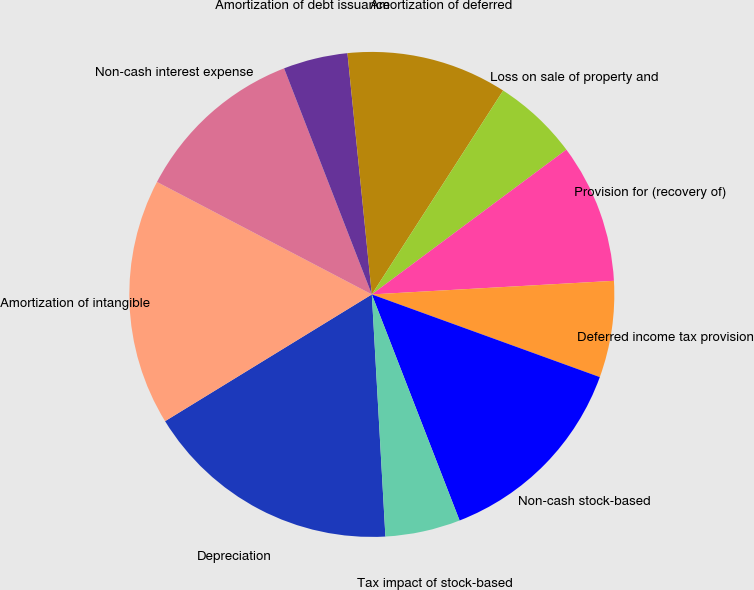Convert chart to OTSL. <chart><loc_0><loc_0><loc_500><loc_500><pie_chart><fcel>Depreciation<fcel>Amortization of intangible<fcel>Non-cash interest expense<fcel>Amortization of debt issuance<fcel>Amortization of deferred<fcel>Loss on sale of property and<fcel>Provision for (recovery of)<fcel>Deferred income tax provision<fcel>Non-cash stock-based<fcel>Tax impact of stock-based<nl><fcel>17.14%<fcel>16.43%<fcel>11.43%<fcel>4.29%<fcel>10.71%<fcel>5.71%<fcel>9.29%<fcel>6.43%<fcel>13.57%<fcel>5.0%<nl></chart> 